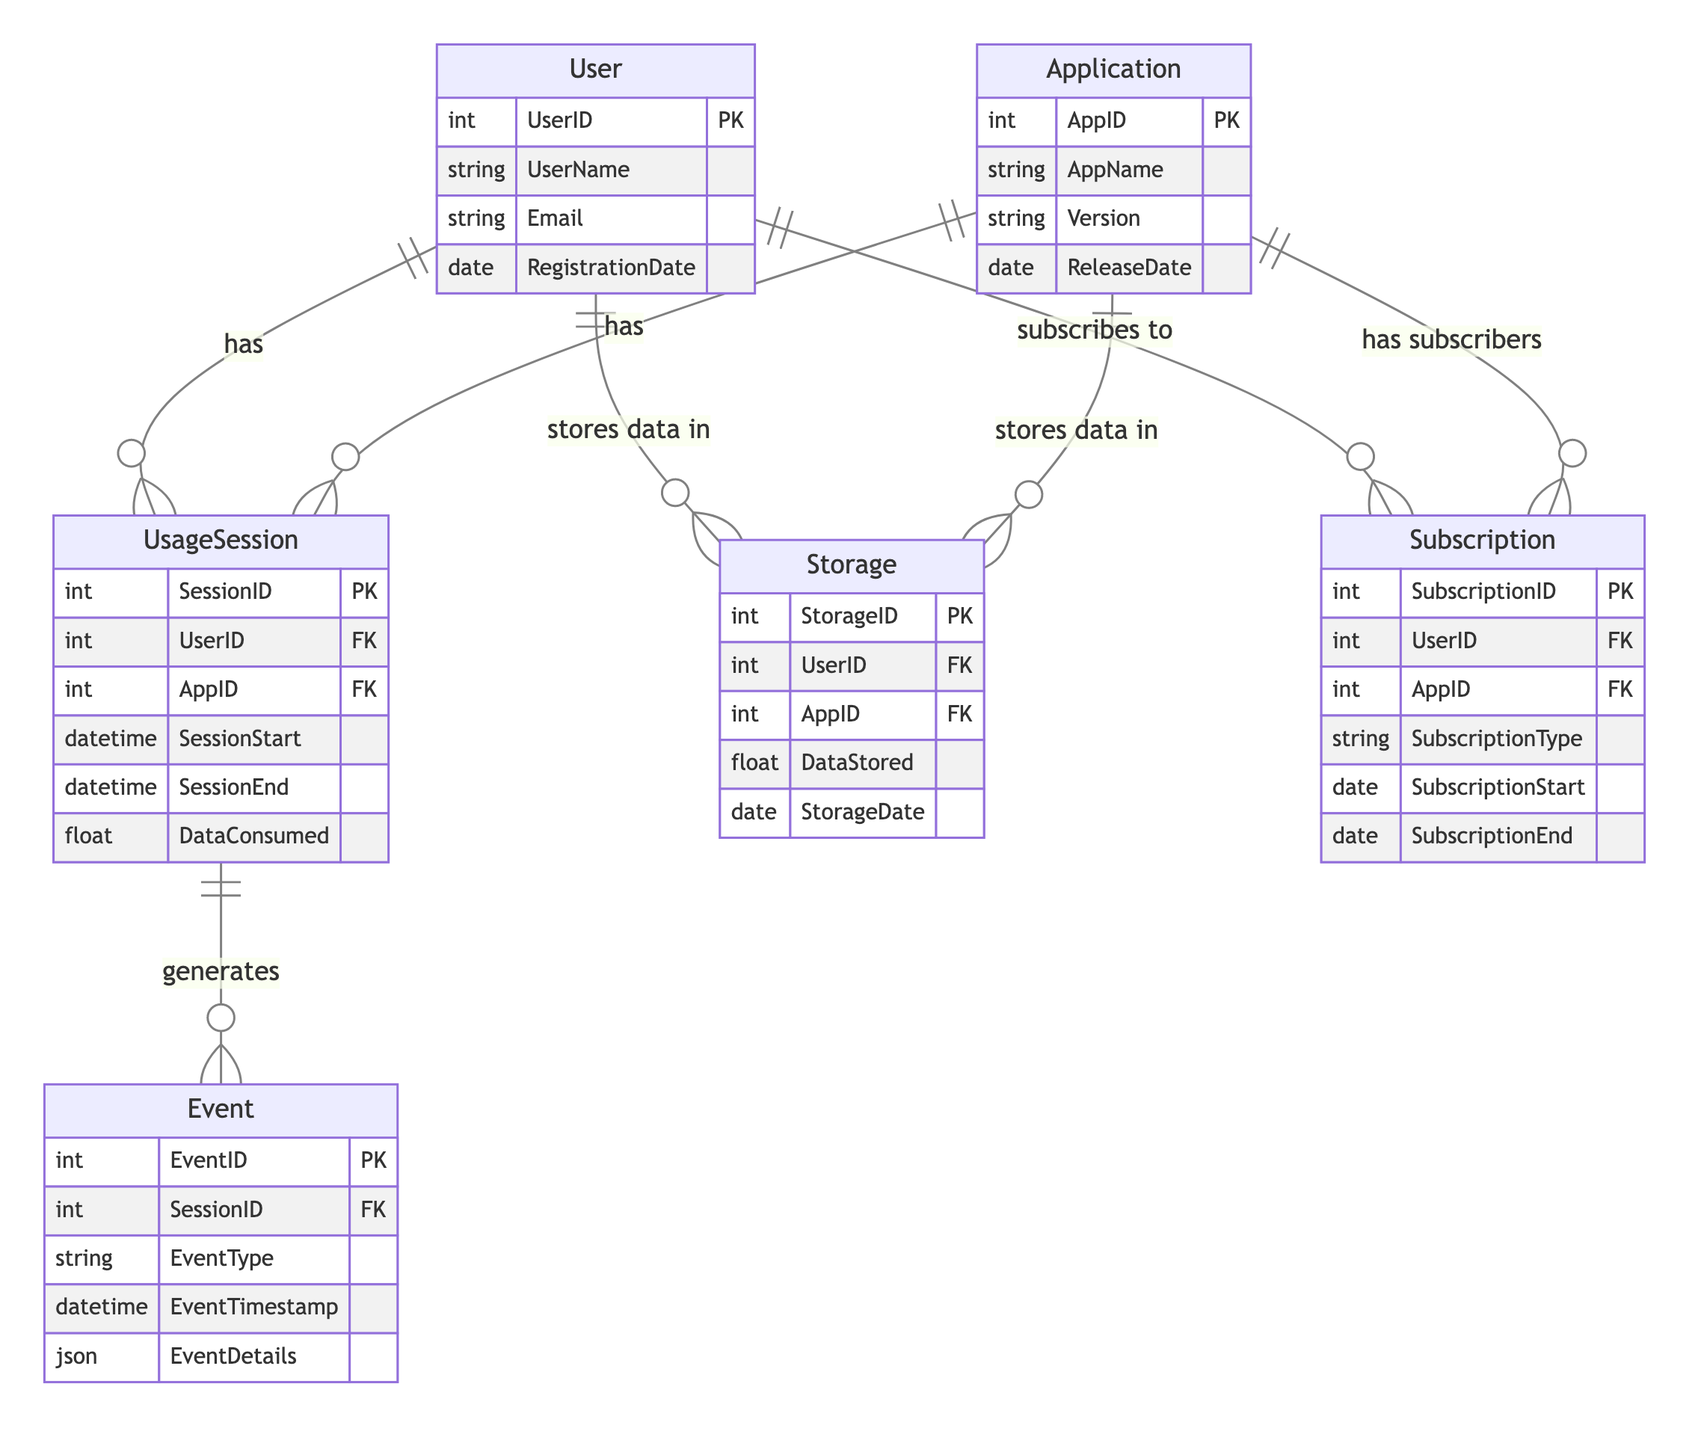What is the primary key of the User entity? The primary key of the User entity is UserID, which uniquely identifies each user in the system as specified in the diagram.
Answer: UserID How many attributes does the Application entity have? The Application entity has four attributes: AppID, AppName, Version, and ReleaseDate as shown in the diagram.
Answer: 4 What type of relationship exists between User and Subscription? The User and Subscription entities have a One-to-Many relationship, indicating that a user can have multiple subscriptions, as depicted in the diagram.
Answer: One-to-Many What does the Event entity generate? The Event entity generates multiple events linked to a specific session, as indicated by the One-to-Many relationship between UsageSession and Event in the diagram.
Answer: Events What is the foreign key in the UsageSession entity? The foreign keys in the UsageSession entity are UserID and AppID, which reference the primary keys from the User and Application entities, respectively, as indicated in the diagram.
Answer: UserID, AppID How many One-to-Many relationships are shown in the diagram? The diagram illustrates six One-to-Many relationships connecting various entities, highlighting how multiple records can relate to a single record in another entity.
Answer: 6 Which entity can store data? Both the User and Application entities can store data as they have a direct relationship with the Storage entity, indicating they both can have storage records associated with them, according to the diagram.
Answer: User, Application What type of data does the Storage entity keep? The Storage entity keeps records related to data stored, specifically DataStored and StorageDate, reflecting on the data about storage for users and applications in the diagram.
Answer: DataStored, StorageDate What defines a subscription in this context? A subscription is defined by SubscriptionType, SubscriptionStart, and SubscriptionEnd, which represent the characteristics of the subscription in relation to the user and application in the diagram.
Answer: SubscriptionType, SubscriptionStart, SubscriptionEnd 